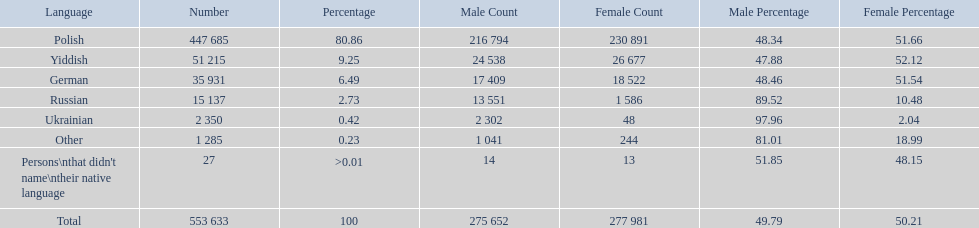What are the percentages of people? 80.86, 9.25, 6.49, 2.73, 0.42, 0.23, >0.01. Which language is .42%? Ukrainian. 